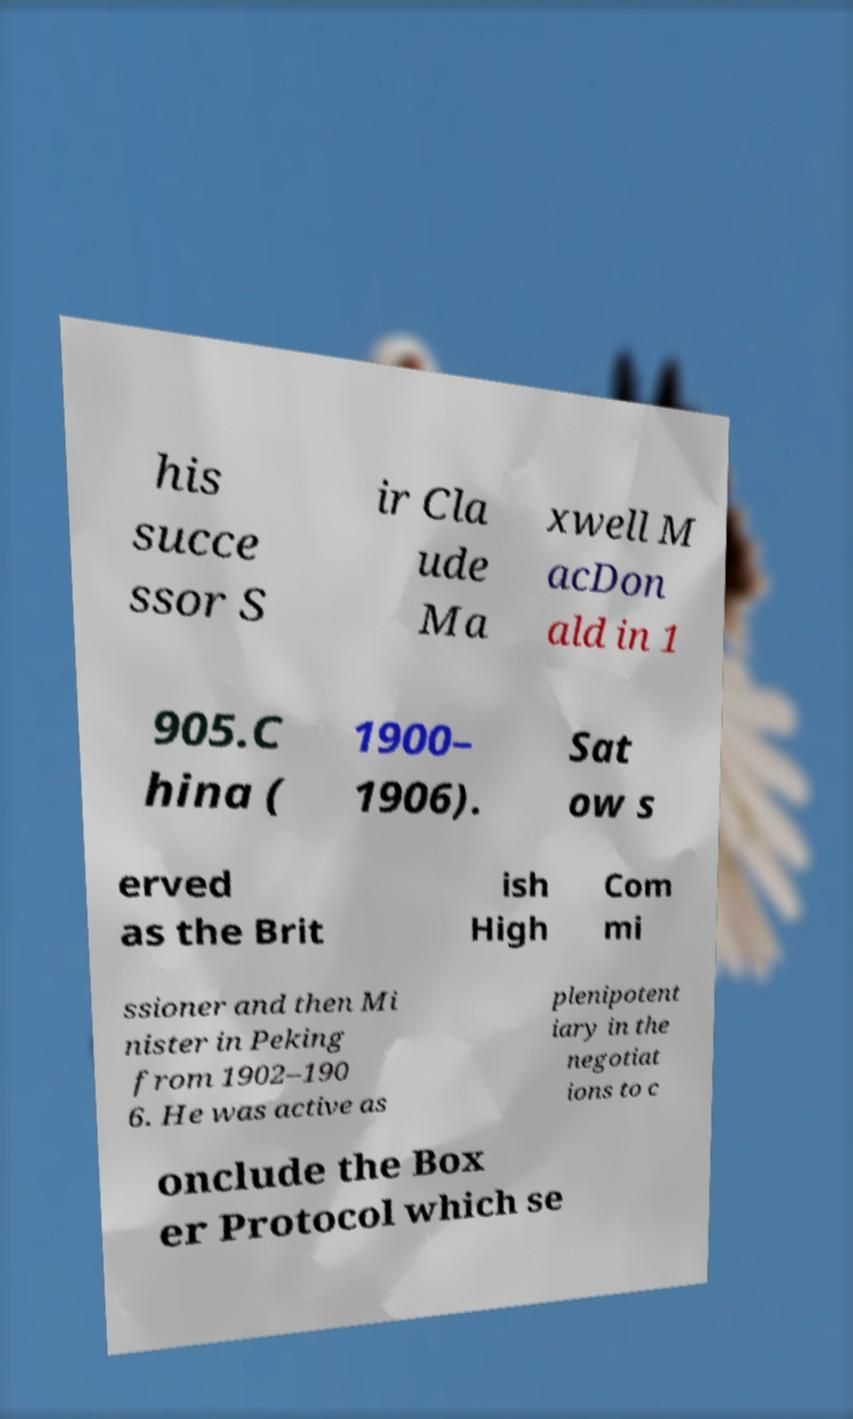I need the written content from this picture converted into text. Can you do that? his succe ssor S ir Cla ude Ma xwell M acDon ald in 1 905.C hina ( 1900– 1906). Sat ow s erved as the Brit ish High Com mi ssioner and then Mi nister in Peking from 1902–190 6. He was active as plenipotent iary in the negotiat ions to c onclude the Box er Protocol which se 